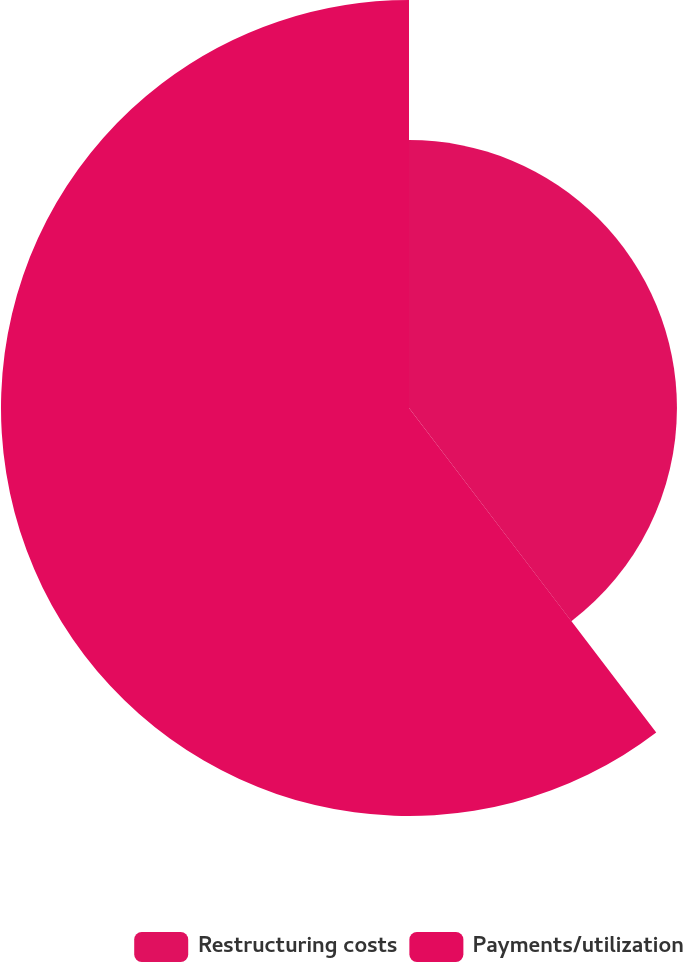Convert chart to OTSL. <chart><loc_0><loc_0><loc_500><loc_500><pie_chart><fcel>Restructuring costs<fcel>Payments/utilization<nl><fcel>39.64%<fcel>60.36%<nl></chart> 